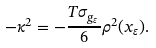Convert formula to latex. <formula><loc_0><loc_0><loc_500><loc_500>- \kappa ^ { 2 } = - \frac { T \sigma _ { g _ { \varepsilon } } } { 6 } \rho ^ { 2 } ( x _ { \varepsilon } ) .</formula> 